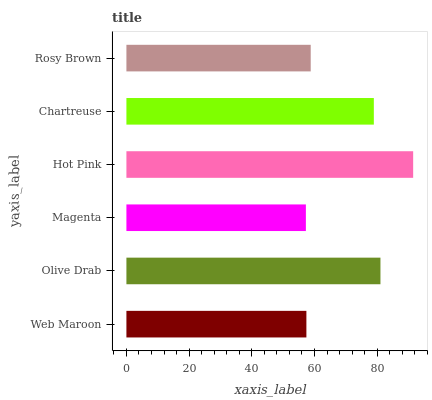Is Magenta the minimum?
Answer yes or no. Yes. Is Hot Pink the maximum?
Answer yes or no. Yes. Is Olive Drab the minimum?
Answer yes or no. No. Is Olive Drab the maximum?
Answer yes or no. No. Is Olive Drab greater than Web Maroon?
Answer yes or no. Yes. Is Web Maroon less than Olive Drab?
Answer yes or no. Yes. Is Web Maroon greater than Olive Drab?
Answer yes or no. No. Is Olive Drab less than Web Maroon?
Answer yes or no. No. Is Chartreuse the high median?
Answer yes or no. Yes. Is Rosy Brown the low median?
Answer yes or no. Yes. Is Olive Drab the high median?
Answer yes or no. No. Is Olive Drab the low median?
Answer yes or no. No. 